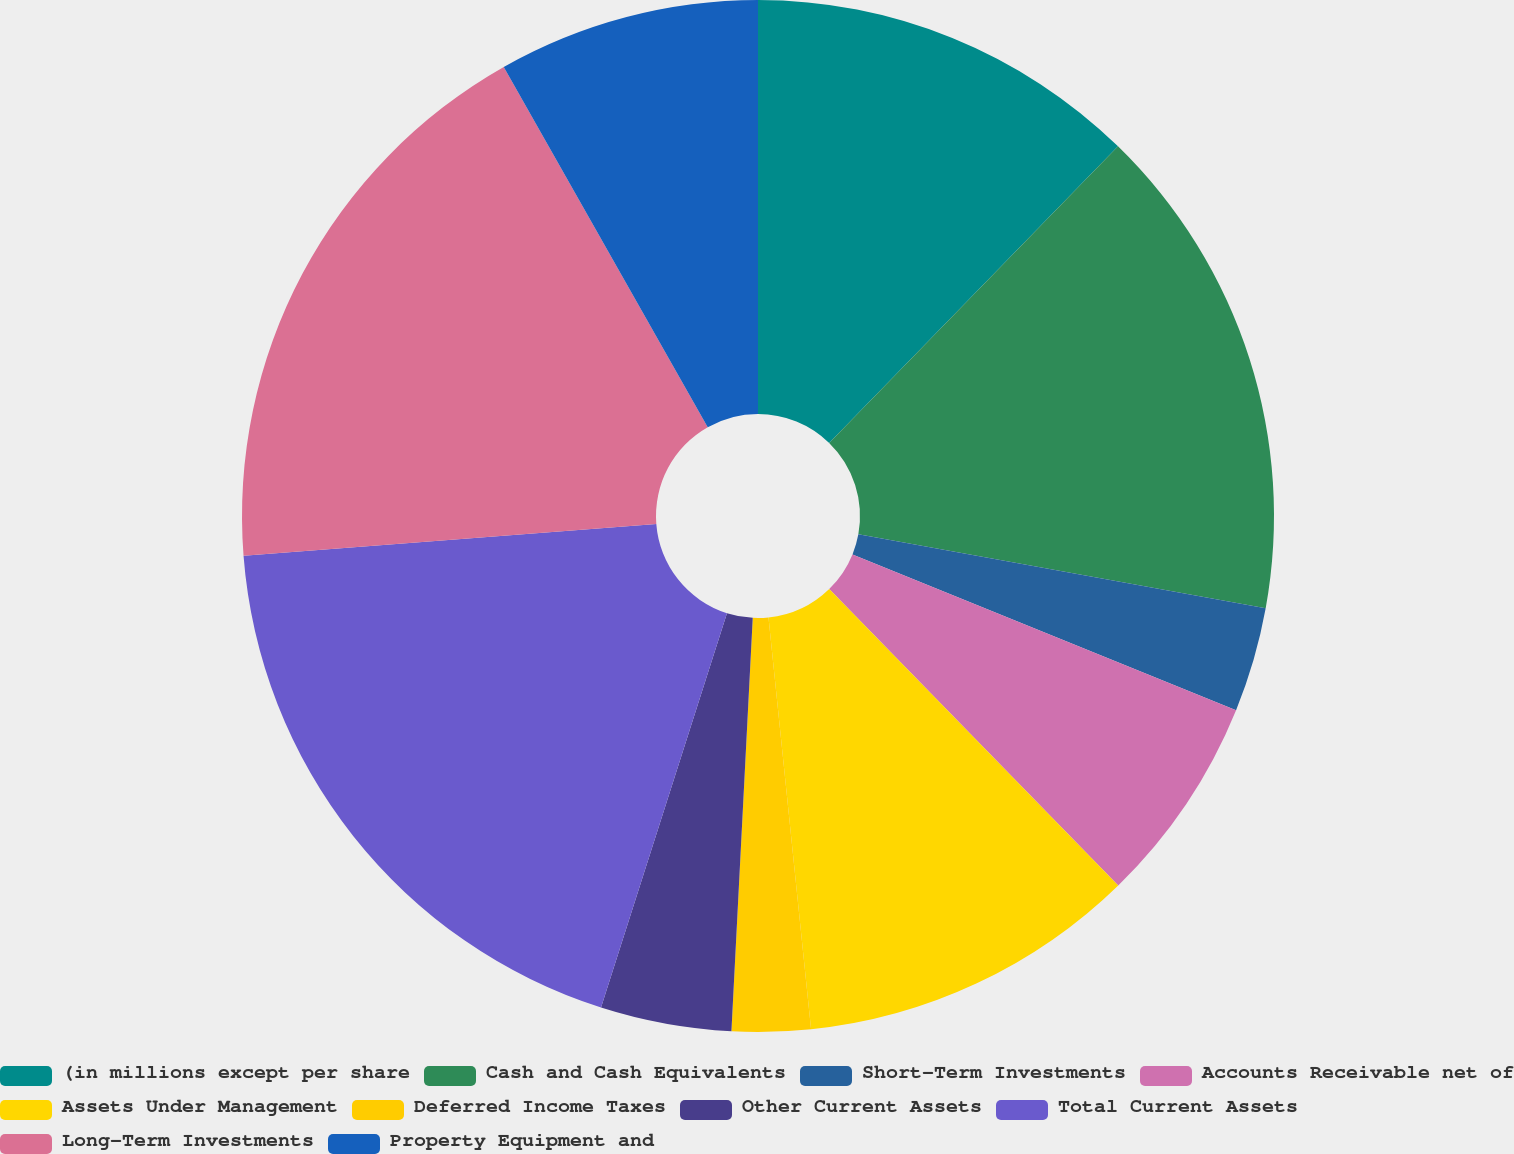Convert chart to OTSL. <chart><loc_0><loc_0><loc_500><loc_500><pie_chart><fcel>(in millions except per share<fcel>Cash and Cash Equivalents<fcel>Short-Term Investments<fcel>Accounts Receivable net of<fcel>Assets Under Management<fcel>Deferred Income Taxes<fcel>Other Current Assets<fcel>Total Current Assets<fcel>Long-Term Investments<fcel>Property Equipment and<nl><fcel>12.29%<fcel>15.57%<fcel>3.28%<fcel>6.56%<fcel>10.66%<fcel>2.46%<fcel>4.1%<fcel>18.85%<fcel>18.03%<fcel>8.2%<nl></chart> 